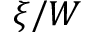<formula> <loc_0><loc_0><loc_500><loc_500>\xi / W</formula> 